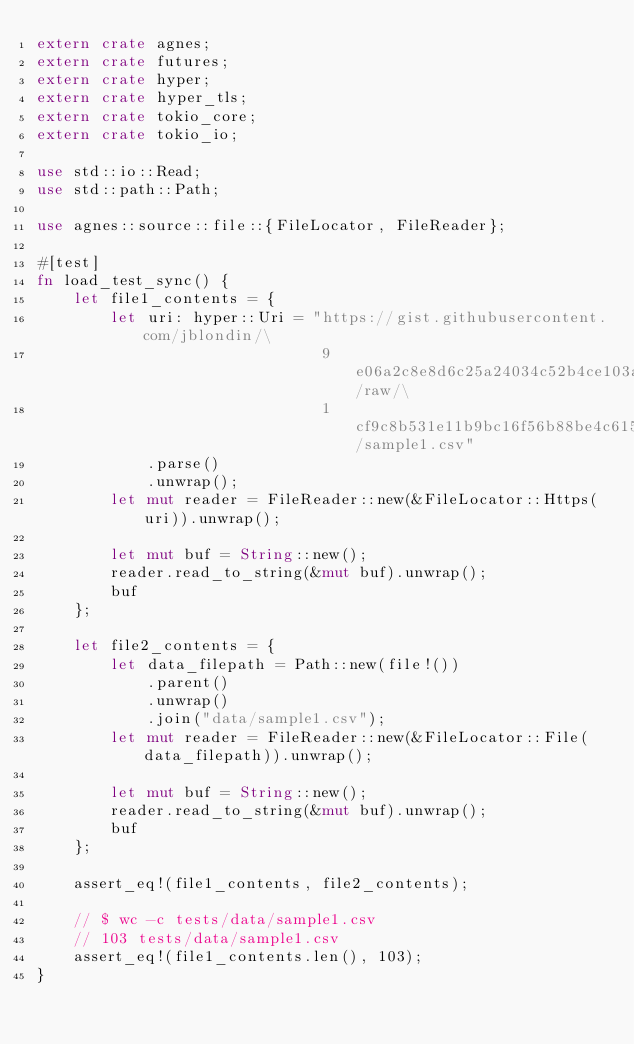<code> <loc_0><loc_0><loc_500><loc_500><_Rust_>extern crate agnes;
extern crate futures;
extern crate hyper;
extern crate hyper_tls;
extern crate tokio_core;
extern crate tokio_io;

use std::io::Read;
use std::path::Path;

use agnes::source::file::{FileLocator, FileReader};

#[test]
fn load_test_sync() {
    let file1_contents = {
        let uri: hyper::Uri = "https://gist.githubusercontent.com/jblondin/\
                               9e06a2c8e8d6c25a24034c52b4ce103a/raw/\
                               1cf9c8b531e11b9bc16f56b88be4c615dc103eb1/sample1.csv"
            .parse()
            .unwrap();
        let mut reader = FileReader::new(&FileLocator::Https(uri)).unwrap();

        let mut buf = String::new();
        reader.read_to_string(&mut buf).unwrap();
        buf
    };

    let file2_contents = {
        let data_filepath = Path::new(file!())
            .parent()
            .unwrap()
            .join("data/sample1.csv");
        let mut reader = FileReader::new(&FileLocator::File(data_filepath)).unwrap();

        let mut buf = String::new();
        reader.read_to_string(&mut buf).unwrap();
        buf
    };

    assert_eq!(file1_contents, file2_contents);

    // $ wc -c tests/data/sample1.csv
    // 103 tests/data/sample1.csv
    assert_eq!(file1_contents.len(), 103);
}
</code> 